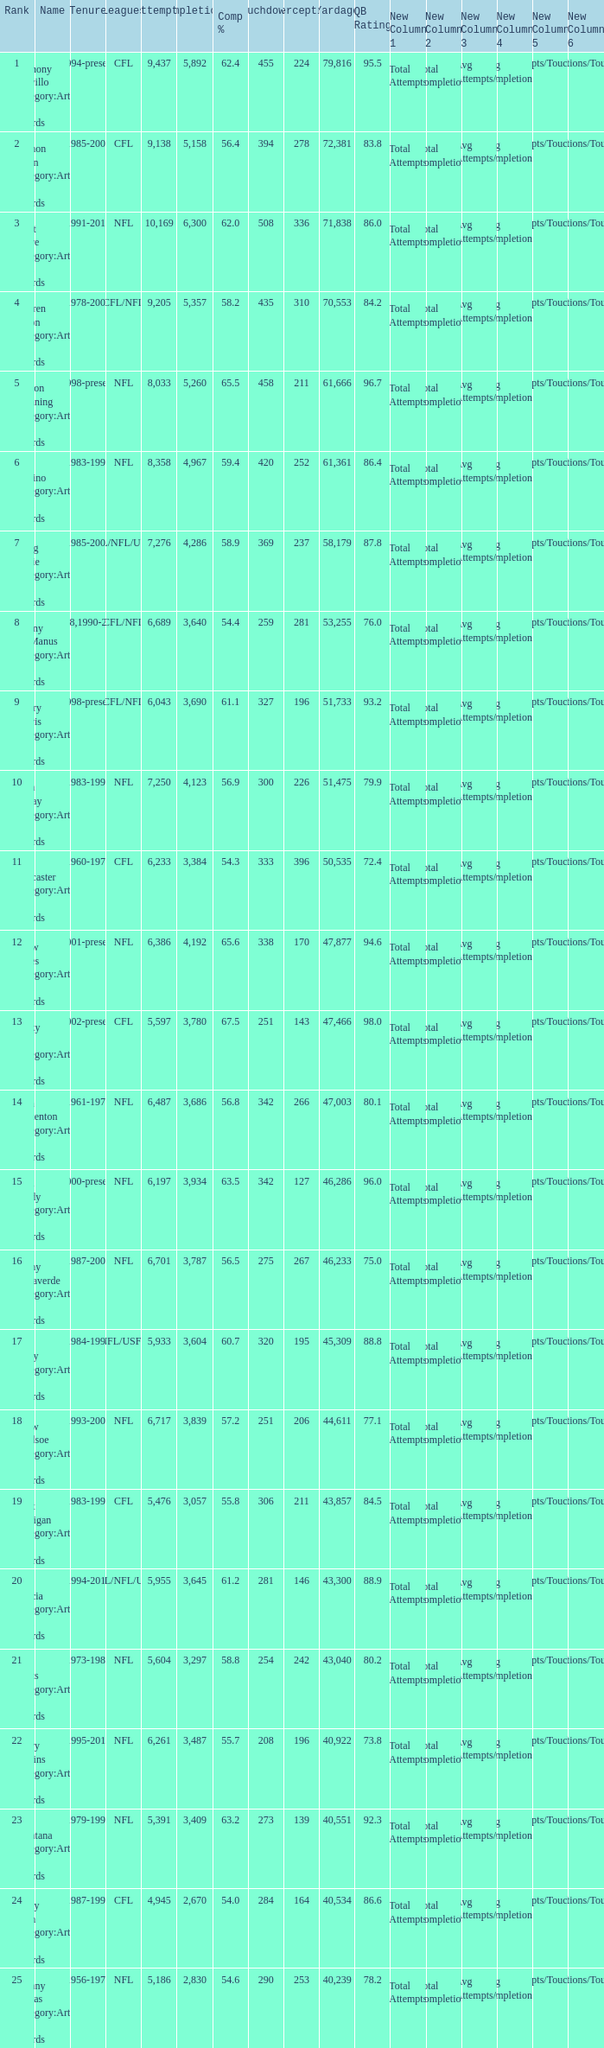What is the number of interceptions with less than 3,487 completions , more than 40,551 yardage, and the comp % is 55.8? 211.0. 